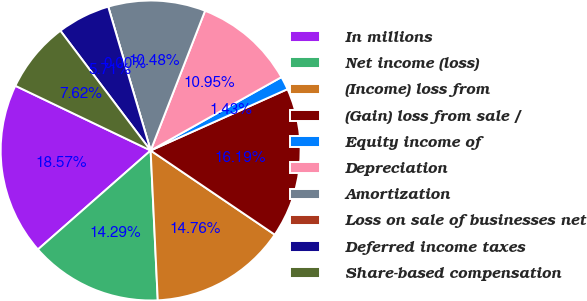<chart> <loc_0><loc_0><loc_500><loc_500><pie_chart><fcel>In millions<fcel>Net income (loss)<fcel>(Income) loss from<fcel>(Gain) loss from sale /<fcel>Equity income of<fcel>Depreciation<fcel>Amortization<fcel>Loss on sale of businesses net<fcel>Deferred income taxes<fcel>Share-based compensation<nl><fcel>18.57%<fcel>14.29%<fcel>14.76%<fcel>16.19%<fcel>1.43%<fcel>10.95%<fcel>10.48%<fcel>0.0%<fcel>5.71%<fcel>7.62%<nl></chart> 